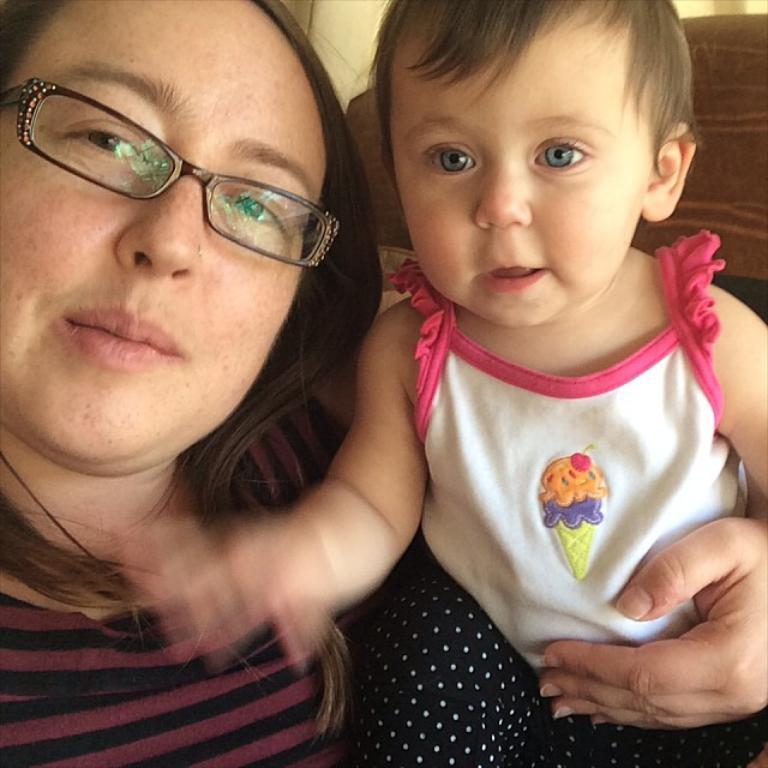Who is present in the image? There is a woman and a child in the image. Can you describe the relationship between the woman and the child? The relationship between the woman and the child is not specified in the image. What is the child doing in the image? The actions of the child is performing are not specified in the image. What type of trees can be seen in the background of the image? There is no background or trees present in the image; it only features a woman and a child. 